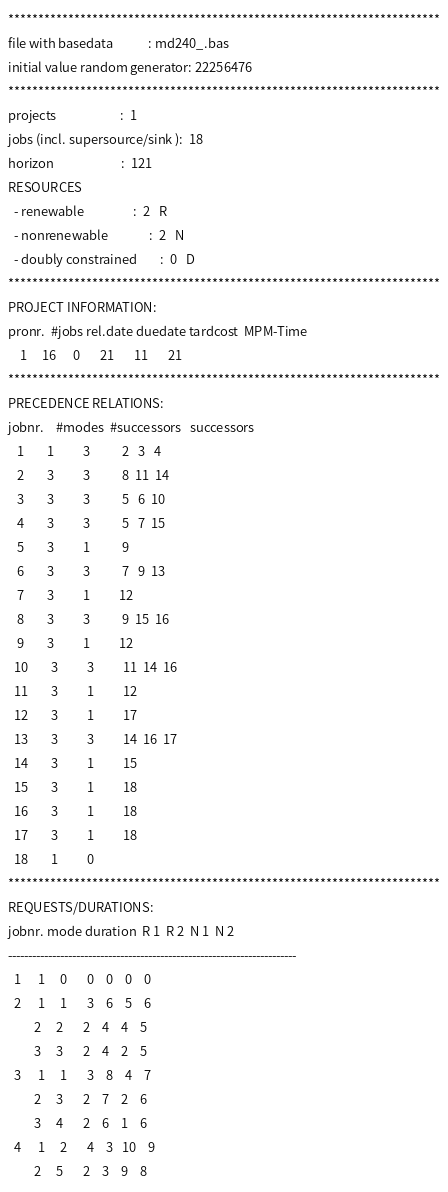<code> <loc_0><loc_0><loc_500><loc_500><_ObjectiveC_>************************************************************************
file with basedata            : md240_.bas
initial value random generator: 22256476
************************************************************************
projects                      :  1
jobs (incl. supersource/sink ):  18
horizon                       :  121
RESOURCES
  - renewable                 :  2   R
  - nonrenewable              :  2   N
  - doubly constrained        :  0   D
************************************************************************
PROJECT INFORMATION:
pronr.  #jobs rel.date duedate tardcost  MPM-Time
    1     16      0       21       11       21
************************************************************************
PRECEDENCE RELATIONS:
jobnr.    #modes  #successors   successors
   1        1          3           2   3   4
   2        3          3           8  11  14
   3        3          3           5   6  10
   4        3          3           5   7  15
   5        3          1           9
   6        3          3           7   9  13
   7        3          1          12
   8        3          3           9  15  16
   9        3          1          12
  10        3          3          11  14  16
  11        3          1          12
  12        3          1          17
  13        3          3          14  16  17
  14        3          1          15
  15        3          1          18
  16        3          1          18
  17        3          1          18
  18        1          0        
************************************************************************
REQUESTS/DURATIONS:
jobnr. mode duration  R 1  R 2  N 1  N 2
------------------------------------------------------------------------
  1      1     0       0    0    0    0
  2      1     1       3    6    5    6
         2     2       2    4    4    5
         3     3       2    4    2    5
  3      1     1       3    8    4    7
         2     3       2    7    2    6
         3     4       2    6    1    6
  4      1     2       4    3   10    9
         2     5       2    3    9    8</code> 